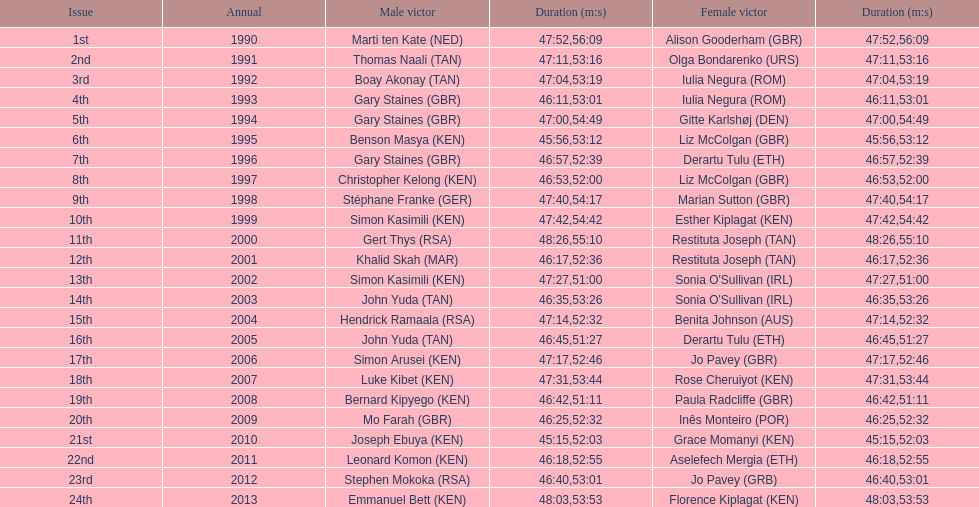What is the number of times, between 1990 and 2013, for britain not to win the men's or women's bupa great south run? 13. 